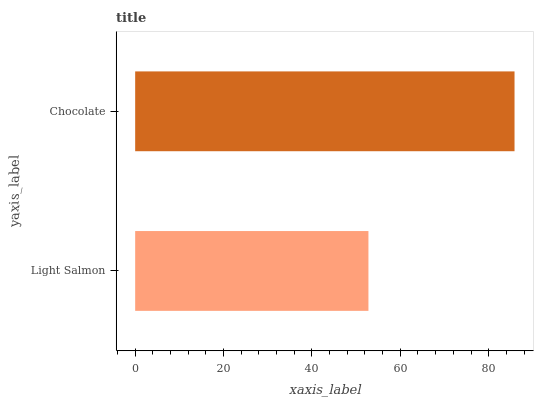Is Light Salmon the minimum?
Answer yes or no. Yes. Is Chocolate the maximum?
Answer yes or no. Yes. Is Chocolate the minimum?
Answer yes or no. No. Is Chocolate greater than Light Salmon?
Answer yes or no. Yes. Is Light Salmon less than Chocolate?
Answer yes or no. Yes. Is Light Salmon greater than Chocolate?
Answer yes or no. No. Is Chocolate less than Light Salmon?
Answer yes or no. No. Is Chocolate the high median?
Answer yes or no. Yes. Is Light Salmon the low median?
Answer yes or no. Yes. Is Light Salmon the high median?
Answer yes or no. No. Is Chocolate the low median?
Answer yes or no. No. 